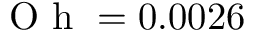<formula> <loc_0><loc_0><loc_500><loc_500>O h = 0 . 0 0 2 6</formula> 